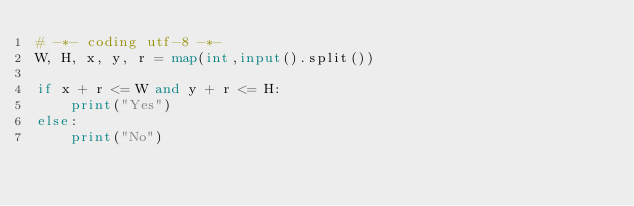<code> <loc_0><loc_0><loc_500><loc_500><_Python_># -*- coding utf-8 -*-
W, H, x, y, r = map(int,input().split())

if x + r <= W and y + r <= H:
    print("Yes")
else:
    print("No")</code> 